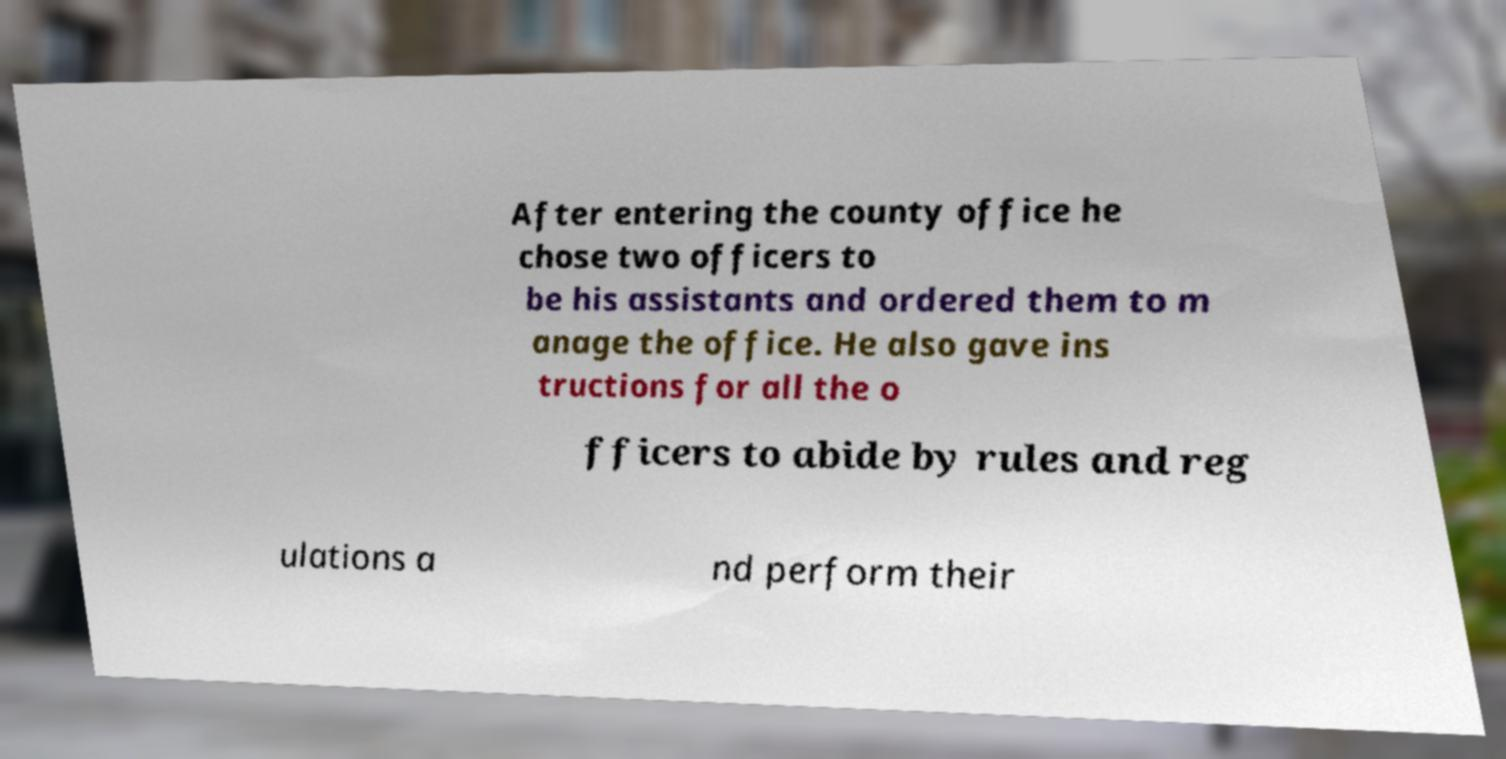Could you assist in decoding the text presented in this image and type it out clearly? After entering the county office he chose two officers to be his assistants and ordered them to m anage the office. He also gave ins tructions for all the o fficers to abide by rules and reg ulations a nd perform their 